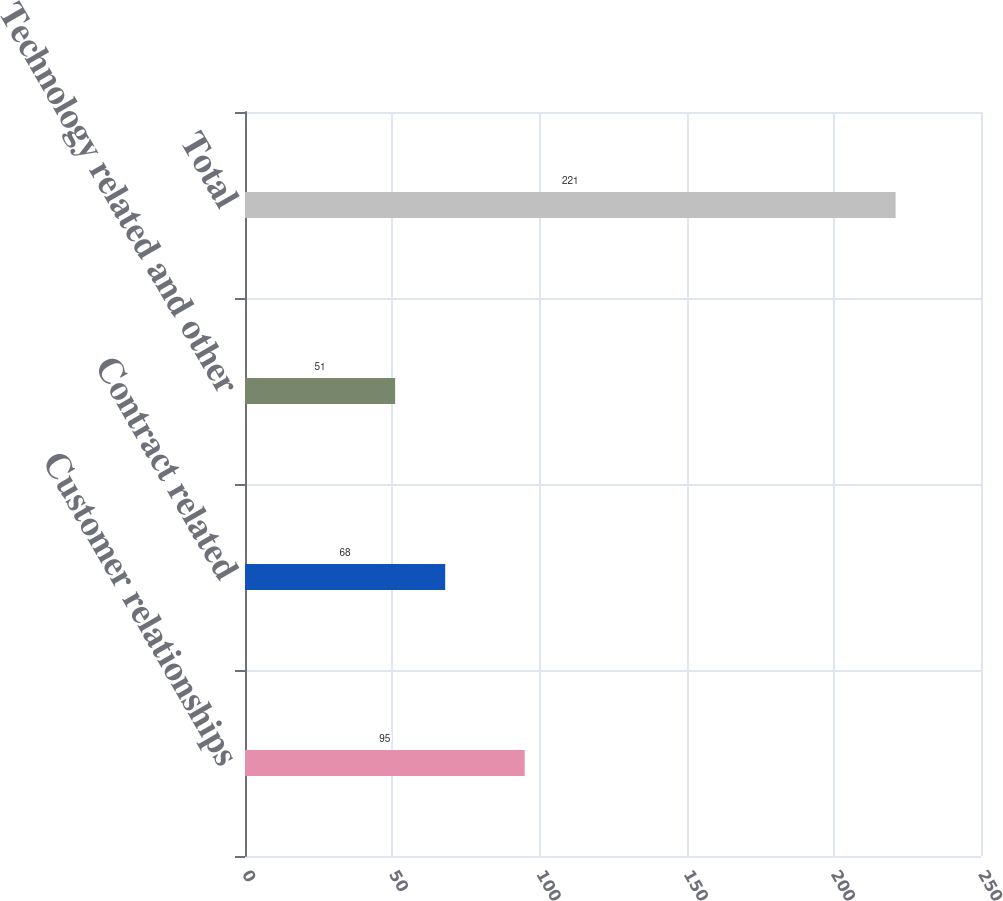Convert chart to OTSL. <chart><loc_0><loc_0><loc_500><loc_500><bar_chart><fcel>Customer relationships<fcel>Contract related<fcel>Technology related and other<fcel>Total<nl><fcel>95<fcel>68<fcel>51<fcel>221<nl></chart> 